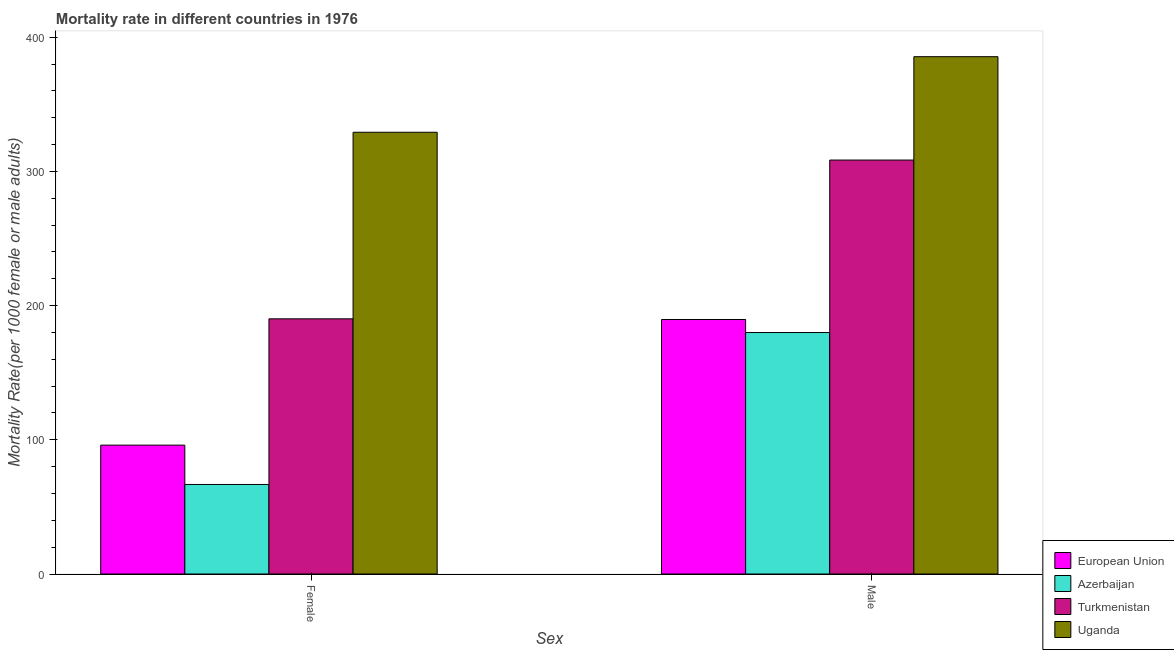How many different coloured bars are there?
Keep it short and to the point. 4. How many groups of bars are there?
Provide a short and direct response. 2. Are the number of bars per tick equal to the number of legend labels?
Keep it short and to the point. Yes. Are the number of bars on each tick of the X-axis equal?
Ensure brevity in your answer.  Yes. How many bars are there on the 1st tick from the right?
Offer a terse response. 4. What is the label of the 1st group of bars from the left?
Provide a succinct answer. Female. What is the male mortality rate in Uganda?
Provide a succinct answer. 385.52. Across all countries, what is the maximum male mortality rate?
Keep it short and to the point. 385.52. Across all countries, what is the minimum male mortality rate?
Ensure brevity in your answer.  179.95. In which country was the male mortality rate maximum?
Provide a succinct answer. Uganda. In which country was the male mortality rate minimum?
Ensure brevity in your answer.  Azerbaijan. What is the total male mortality rate in the graph?
Your answer should be compact. 1063.62. What is the difference between the male mortality rate in Uganda and that in European Union?
Make the answer very short. 195.85. What is the difference between the male mortality rate in Azerbaijan and the female mortality rate in Uganda?
Keep it short and to the point. -149.24. What is the average female mortality rate per country?
Offer a very short reply. 170.53. What is the difference between the female mortality rate and male mortality rate in Uganda?
Offer a very short reply. -56.32. What is the ratio of the male mortality rate in Turkmenistan to that in European Union?
Keep it short and to the point. 1.63. What does the 4th bar from the right in Female represents?
Offer a terse response. European Union. How many bars are there?
Keep it short and to the point. 8. Are all the bars in the graph horizontal?
Your answer should be very brief. No. How many countries are there in the graph?
Offer a very short reply. 4. Are the values on the major ticks of Y-axis written in scientific E-notation?
Provide a succinct answer. No. Where does the legend appear in the graph?
Provide a short and direct response. Bottom right. How many legend labels are there?
Offer a very short reply. 4. What is the title of the graph?
Ensure brevity in your answer.  Mortality rate in different countries in 1976. What is the label or title of the X-axis?
Provide a succinct answer. Sex. What is the label or title of the Y-axis?
Ensure brevity in your answer.  Mortality Rate(per 1000 female or male adults). What is the Mortality Rate(per 1000 female or male adults) of European Union in Female?
Provide a short and direct response. 96.03. What is the Mortality Rate(per 1000 female or male adults) of Azerbaijan in Female?
Provide a short and direct response. 66.73. What is the Mortality Rate(per 1000 female or male adults) in Turkmenistan in Female?
Offer a very short reply. 190.16. What is the Mortality Rate(per 1000 female or male adults) of Uganda in Female?
Offer a very short reply. 329.2. What is the Mortality Rate(per 1000 female or male adults) in European Union in Male?
Provide a short and direct response. 189.66. What is the Mortality Rate(per 1000 female or male adults) in Azerbaijan in Male?
Your answer should be very brief. 179.95. What is the Mortality Rate(per 1000 female or male adults) of Turkmenistan in Male?
Ensure brevity in your answer.  308.49. What is the Mortality Rate(per 1000 female or male adults) in Uganda in Male?
Offer a very short reply. 385.52. Across all Sex, what is the maximum Mortality Rate(per 1000 female or male adults) of European Union?
Keep it short and to the point. 189.66. Across all Sex, what is the maximum Mortality Rate(per 1000 female or male adults) in Azerbaijan?
Provide a short and direct response. 179.95. Across all Sex, what is the maximum Mortality Rate(per 1000 female or male adults) in Turkmenistan?
Give a very brief answer. 308.49. Across all Sex, what is the maximum Mortality Rate(per 1000 female or male adults) in Uganda?
Provide a succinct answer. 385.52. Across all Sex, what is the minimum Mortality Rate(per 1000 female or male adults) of European Union?
Provide a succinct answer. 96.03. Across all Sex, what is the minimum Mortality Rate(per 1000 female or male adults) of Azerbaijan?
Give a very brief answer. 66.73. Across all Sex, what is the minimum Mortality Rate(per 1000 female or male adults) of Turkmenistan?
Provide a succinct answer. 190.16. Across all Sex, what is the minimum Mortality Rate(per 1000 female or male adults) of Uganda?
Give a very brief answer. 329.2. What is the total Mortality Rate(per 1000 female or male adults) of European Union in the graph?
Offer a terse response. 285.7. What is the total Mortality Rate(per 1000 female or male adults) in Azerbaijan in the graph?
Your answer should be very brief. 246.68. What is the total Mortality Rate(per 1000 female or male adults) in Turkmenistan in the graph?
Provide a succinct answer. 498.65. What is the total Mortality Rate(per 1000 female or male adults) of Uganda in the graph?
Keep it short and to the point. 714.72. What is the difference between the Mortality Rate(per 1000 female or male adults) in European Union in Female and that in Male?
Provide a short and direct response. -93.63. What is the difference between the Mortality Rate(per 1000 female or male adults) in Azerbaijan in Female and that in Male?
Your response must be concise. -113.23. What is the difference between the Mortality Rate(per 1000 female or male adults) of Turkmenistan in Female and that in Male?
Provide a short and direct response. -118.32. What is the difference between the Mortality Rate(per 1000 female or male adults) of Uganda in Female and that in Male?
Make the answer very short. -56.32. What is the difference between the Mortality Rate(per 1000 female or male adults) in European Union in Female and the Mortality Rate(per 1000 female or male adults) in Azerbaijan in Male?
Give a very brief answer. -83.92. What is the difference between the Mortality Rate(per 1000 female or male adults) in European Union in Female and the Mortality Rate(per 1000 female or male adults) in Turkmenistan in Male?
Your response must be concise. -212.45. What is the difference between the Mortality Rate(per 1000 female or male adults) in European Union in Female and the Mortality Rate(per 1000 female or male adults) in Uganda in Male?
Offer a terse response. -289.48. What is the difference between the Mortality Rate(per 1000 female or male adults) in Azerbaijan in Female and the Mortality Rate(per 1000 female or male adults) in Turkmenistan in Male?
Offer a terse response. -241.76. What is the difference between the Mortality Rate(per 1000 female or male adults) of Azerbaijan in Female and the Mortality Rate(per 1000 female or male adults) of Uganda in Male?
Provide a short and direct response. -318.79. What is the difference between the Mortality Rate(per 1000 female or male adults) of Turkmenistan in Female and the Mortality Rate(per 1000 female or male adults) of Uganda in Male?
Provide a short and direct response. -195.35. What is the average Mortality Rate(per 1000 female or male adults) of European Union per Sex?
Provide a short and direct response. 142.85. What is the average Mortality Rate(per 1000 female or male adults) of Azerbaijan per Sex?
Offer a very short reply. 123.34. What is the average Mortality Rate(per 1000 female or male adults) in Turkmenistan per Sex?
Offer a very short reply. 249.32. What is the average Mortality Rate(per 1000 female or male adults) of Uganda per Sex?
Ensure brevity in your answer.  357.36. What is the difference between the Mortality Rate(per 1000 female or male adults) of European Union and Mortality Rate(per 1000 female or male adults) of Azerbaijan in Female?
Keep it short and to the point. 29.31. What is the difference between the Mortality Rate(per 1000 female or male adults) in European Union and Mortality Rate(per 1000 female or male adults) in Turkmenistan in Female?
Provide a short and direct response. -94.13. What is the difference between the Mortality Rate(per 1000 female or male adults) of European Union and Mortality Rate(per 1000 female or male adults) of Uganda in Female?
Your answer should be very brief. -233.16. What is the difference between the Mortality Rate(per 1000 female or male adults) of Azerbaijan and Mortality Rate(per 1000 female or male adults) of Turkmenistan in Female?
Offer a terse response. -123.44. What is the difference between the Mortality Rate(per 1000 female or male adults) of Azerbaijan and Mortality Rate(per 1000 female or male adults) of Uganda in Female?
Keep it short and to the point. -262.47. What is the difference between the Mortality Rate(per 1000 female or male adults) in Turkmenistan and Mortality Rate(per 1000 female or male adults) in Uganda in Female?
Your answer should be very brief. -139.03. What is the difference between the Mortality Rate(per 1000 female or male adults) in European Union and Mortality Rate(per 1000 female or male adults) in Azerbaijan in Male?
Your answer should be compact. 9.71. What is the difference between the Mortality Rate(per 1000 female or male adults) of European Union and Mortality Rate(per 1000 female or male adults) of Turkmenistan in Male?
Keep it short and to the point. -118.82. What is the difference between the Mortality Rate(per 1000 female or male adults) in European Union and Mortality Rate(per 1000 female or male adults) in Uganda in Male?
Make the answer very short. -195.85. What is the difference between the Mortality Rate(per 1000 female or male adults) in Azerbaijan and Mortality Rate(per 1000 female or male adults) in Turkmenistan in Male?
Provide a succinct answer. -128.53. What is the difference between the Mortality Rate(per 1000 female or male adults) in Azerbaijan and Mortality Rate(per 1000 female or male adults) in Uganda in Male?
Provide a succinct answer. -205.56. What is the difference between the Mortality Rate(per 1000 female or male adults) of Turkmenistan and Mortality Rate(per 1000 female or male adults) of Uganda in Male?
Your answer should be very brief. -77.03. What is the ratio of the Mortality Rate(per 1000 female or male adults) in European Union in Female to that in Male?
Provide a short and direct response. 0.51. What is the ratio of the Mortality Rate(per 1000 female or male adults) of Azerbaijan in Female to that in Male?
Your answer should be compact. 0.37. What is the ratio of the Mortality Rate(per 1000 female or male adults) of Turkmenistan in Female to that in Male?
Ensure brevity in your answer.  0.62. What is the ratio of the Mortality Rate(per 1000 female or male adults) in Uganda in Female to that in Male?
Offer a terse response. 0.85. What is the difference between the highest and the second highest Mortality Rate(per 1000 female or male adults) of European Union?
Your answer should be very brief. 93.63. What is the difference between the highest and the second highest Mortality Rate(per 1000 female or male adults) of Azerbaijan?
Provide a succinct answer. 113.23. What is the difference between the highest and the second highest Mortality Rate(per 1000 female or male adults) of Turkmenistan?
Keep it short and to the point. 118.32. What is the difference between the highest and the second highest Mortality Rate(per 1000 female or male adults) of Uganda?
Give a very brief answer. 56.32. What is the difference between the highest and the lowest Mortality Rate(per 1000 female or male adults) of European Union?
Give a very brief answer. 93.63. What is the difference between the highest and the lowest Mortality Rate(per 1000 female or male adults) of Azerbaijan?
Give a very brief answer. 113.23. What is the difference between the highest and the lowest Mortality Rate(per 1000 female or male adults) of Turkmenistan?
Keep it short and to the point. 118.32. What is the difference between the highest and the lowest Mortality Rate(per 1000 female or male adults) of Uganda?
Give a very brief answer. 56.32. 